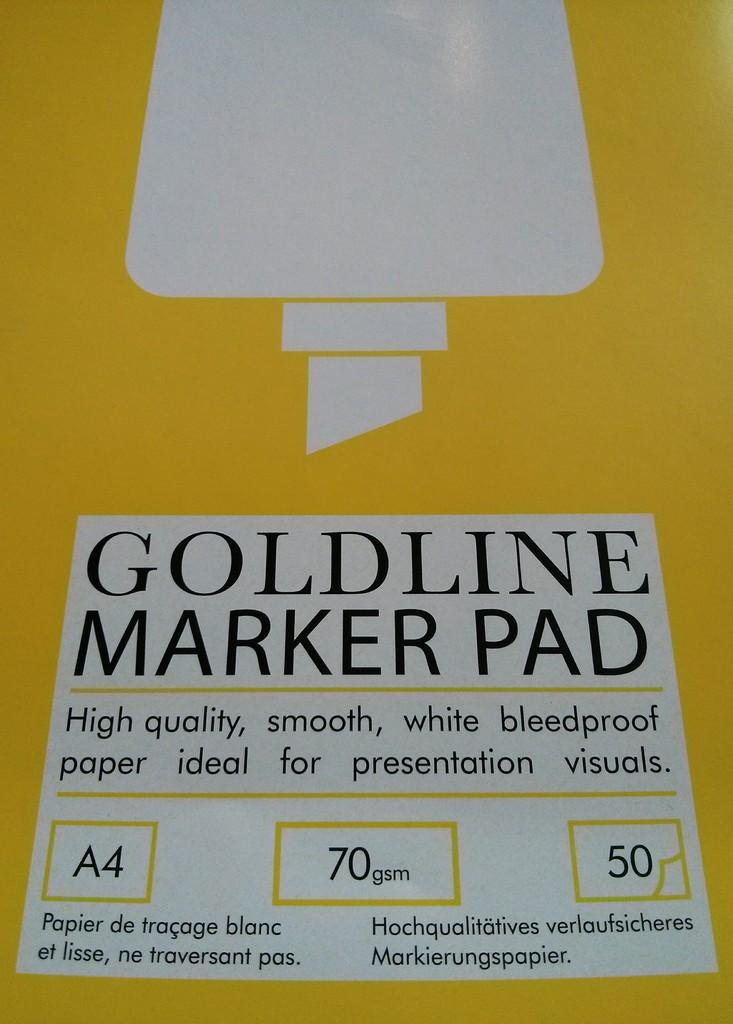<image>
Render a clear and concise summary of the photo. A goldline marker pad the front is yellow and it includes bleedproof paper underneath. 